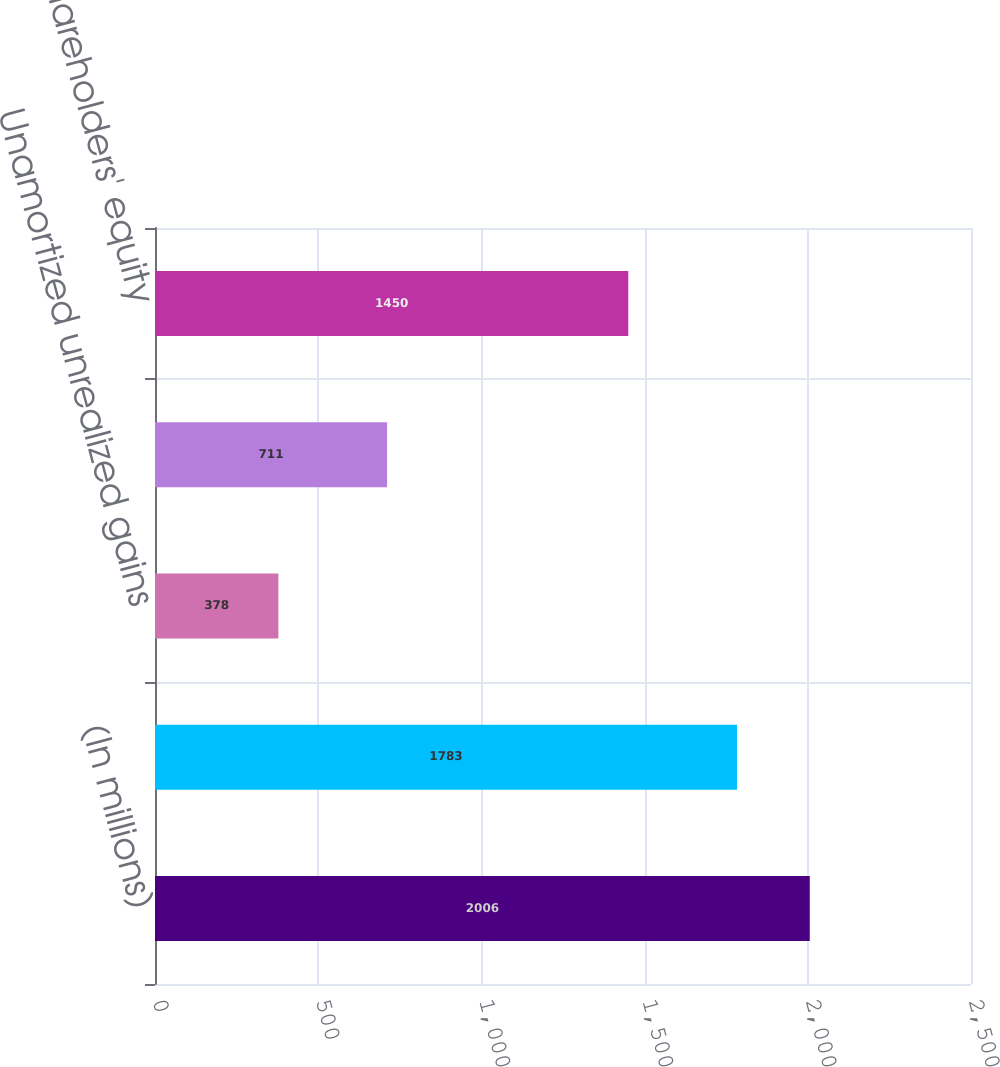<chart> <loc_0><loc_0><loc_500><loc_500><bar_chart><fcel>(In millions)<fcel>Unrealized gains on securities<fcel>Unamortized unrealized gains<fcel>Deferred income taxes<fcel>Shareholders' equity<nl><fcel>2006<fcel>1783<fcel>378<fcel>711<fcel>1450<nl></chart> 